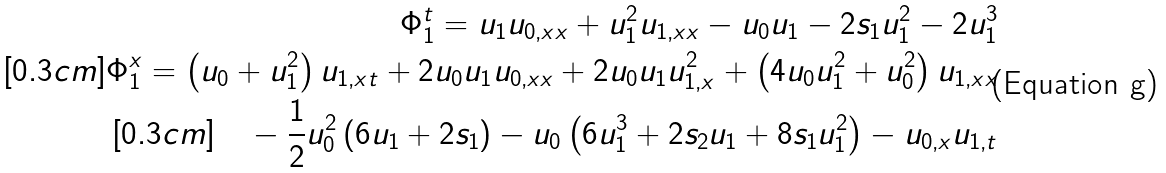<formula> <loc_0><loc_0><loc_500><loc_500>\Phi _ { 1 } ^ { t } = u _ { 1 } u _ { 0 , x x } + u _ { 1 } ^ { 2 } u _ { 1 , x x } - u _ { 0 } u _ { 1 } - 2 s _ { 1 } u _ { 1 } ^ { 2 } - 2 u _ { 1 } ^ { 3 } \\ [ 0 . 3 c m ] \Phi _ { 1 } ^ { x } = \left ( u _ { 0 } + u _ { 1 } ^ { 2 } \right ) u _ { 1 , x t } + 2 u _ { 0 } u _ { 1 } u _ { 0 , x x } + 2 u _ { 0 } u _ { 1 } u _ { 1 , x } ^ { 2 } + \left ( 4 u _ { 0 } u _ { 1 } ^ { 2 } + u _ { 0 } ^ { 2 } \right ) u _ { 1 , x x } \\ [ 0 . 3 c m ] \quad - \frac { 1 } { 2 } u _ { 0 } ^ { 2 } \left ( 6 u _ { 1 } + 2 s _ { 1 } \right ) - u _ { 0 } \left ( 6 u _ { 1 } ^ { 3 } + 2 s _ { 2 } u _ { 1 } + 8 s _ { 1 } u _ { 1 } ^ { 2 } \right ) - u _ { 0 , x } u _ { 1 , t }</formula> 